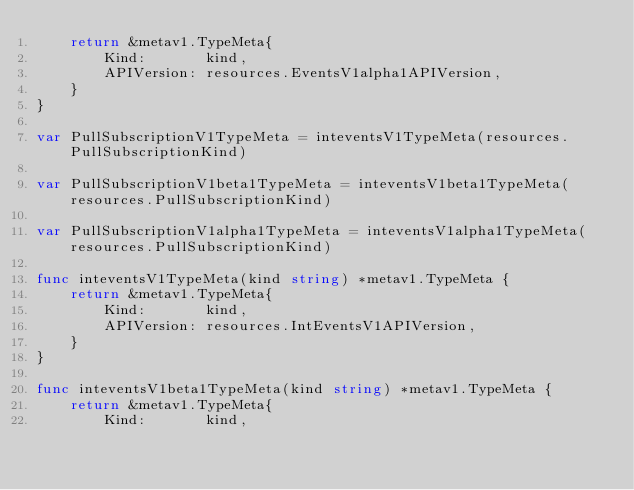<code> <loc_0><loc_0><loc_500><loc_500><_Go_>	return &metav1.TypeMeta{
		Kind:       kind,
		APIVersion: resources.EventsV1alpha1APIVersion,
	}
}

var PullSubscriptionV1TypeMeta = inteventsV1TypeMeta(resources.PullSubscriptionKind)

var PullSubscriptionV1beta1TypeMeta = inteventsV1beta1TypeMeta(resources.PullSubscriptionKind)

var PullSubscriptionV1alpha1TypeMeta = inteventsV1alpha1TypeMeta(resources.PullSubscriptionKind)

func inteventsV1TypeMeta(kind string) *metav1.TypeMeta {
	return &metav1.TypeMeta{
		Kind:       kind,
		APIVersion: resources.IntEventsV1APIVersion,
	}
}

func inteventsV1beta1TypeMeta(kind string) *metav1.TypeMeta {
	return &metav1.TypeMeta{
		Kind:       kind,</code> 